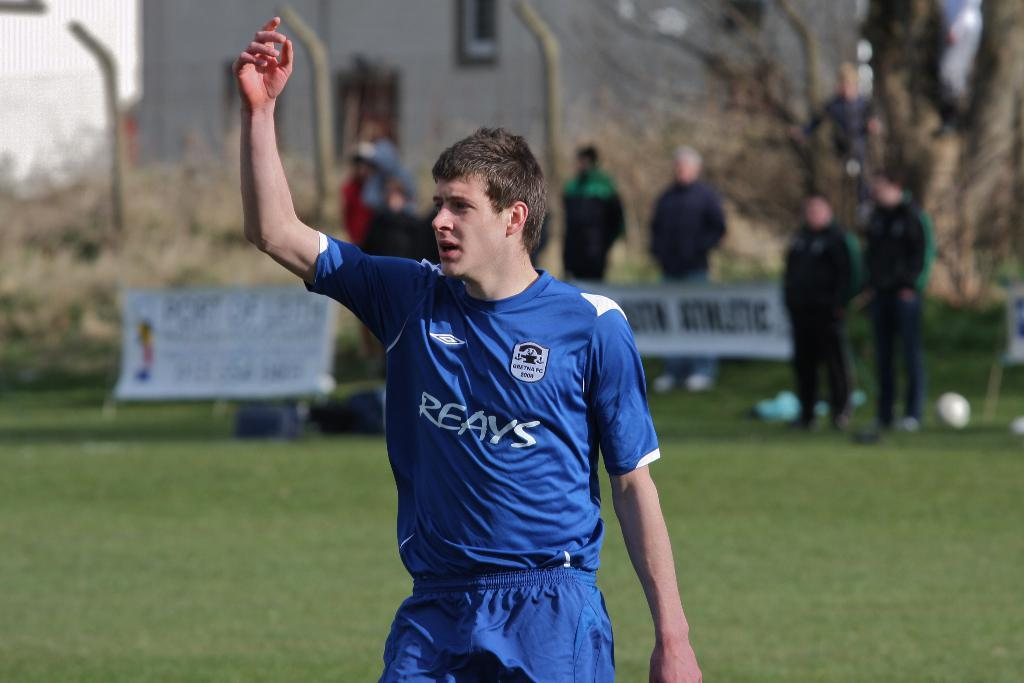<image>
Give a short and clear explanation of the subsequent image. A soccer player stands on a field wearing a blue Reays shirt. 